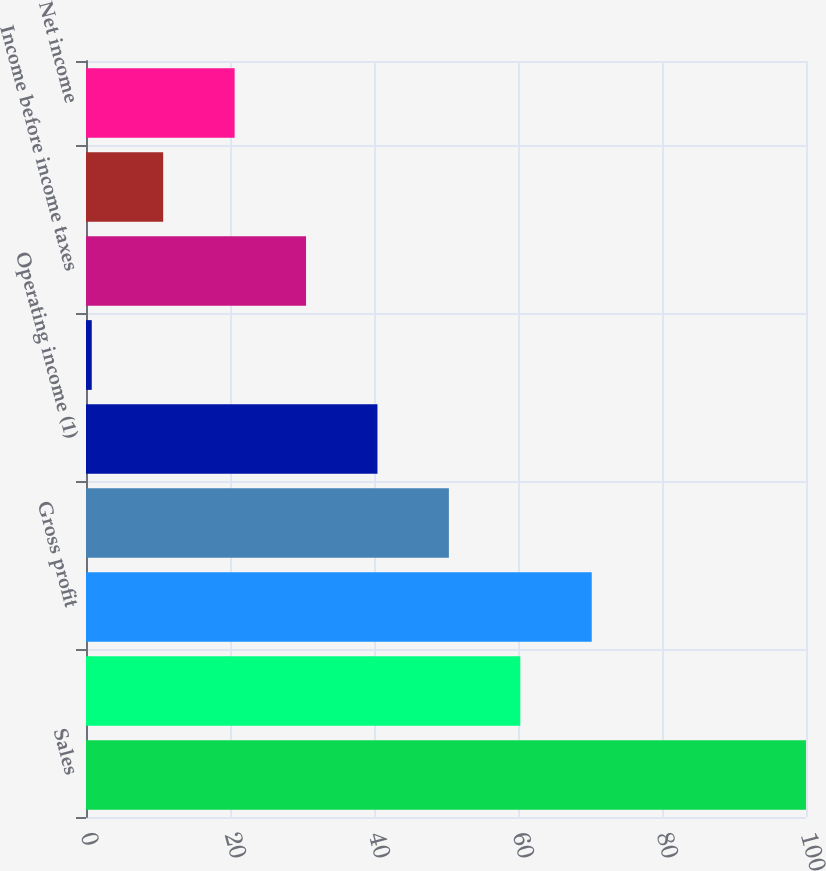Convert chart to OTSL. <chart><loc_0><loc_0><loc_500><loc_500><bar_chart><fcel>Sales<fcel>Cost of goods sold including<fcel>Gross profit<fcel>Selling general and<fcel>Operating income (1)<fcel>Interest expense<fcel>Income before income taxes<fcel>Provision for income taxes<fcel>Net income<nl><fcel>100<fcel>60.32<fcel>70.24<fcel>50.4<fcel>40.48<fcel>0.8<fcel>30.56<fcel>10.72<fcel>20.64<nl></chart> 